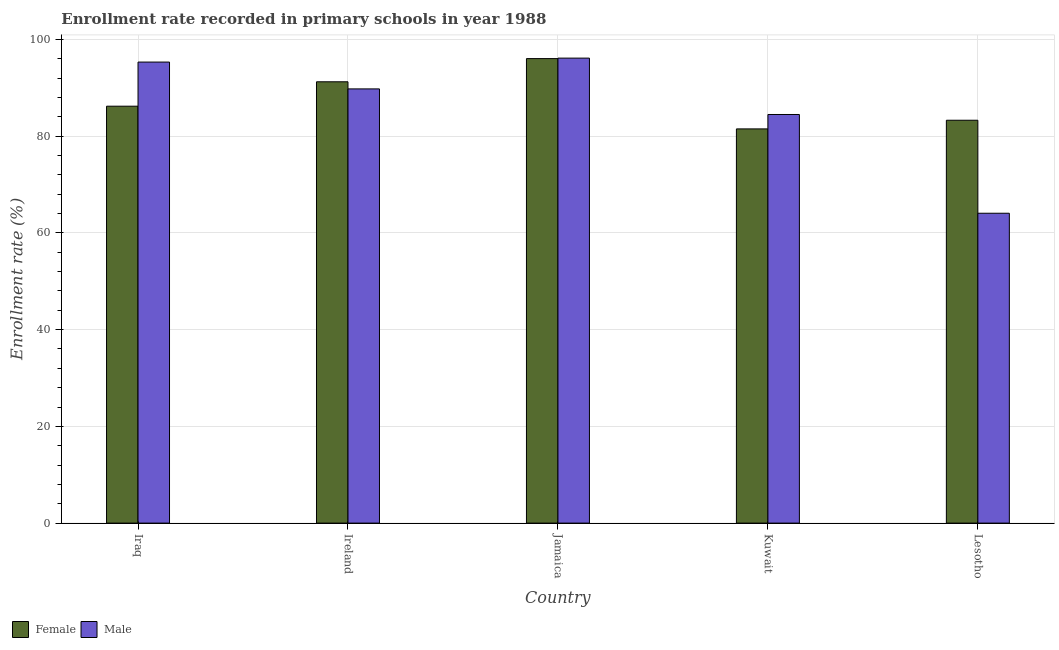How many groups of bars are there?
Provide a succinct answer. 5. Are the number of bars per tick equal to the number of legend labels?
Your answer should be very brief. Yes. How many bars are there on the 3rd tick from the left?
Keep it short and to the point. 2. What is the label of the 1st group of bars from the left?
Give a very brief answer. Iraq. What is the enrollment rate of male students in Lesotho?
Offer a very short reply. 64.07. Across all countries, what is the maximum enrollment rate of female students?
Offer a very short reply. 96.05. Across all countries, what is the minimum enrollment rate of male students?
Provide a succinct answer. 64.07. In which country was the enrollment rate of female students maximum?
Provide a short and direct response. Jamaica. In which country was the enrollment rate of female students minimum?
Your answer should be compact. Kuwait. What is the total enrollment rate of male students in the graph?
Keep it short and to the point. 429.81. What is the difference between the enrollment rate of female students in Iraq and that in Lesotho?
Ensure brevity in your answer.  2.9. What is the difference between the enrollment rate of female students in Iraq and the enrollment rate of male students in Jamaica?
Provide a short and direct response. -9.94. What is the average enrollment rate of male students per country?
Your answer should be very brief. 85.96. What is the difference between the enrollment rate of male students and enrollment rate of female students in Ireland?
Make the answer very short. -1.47. What is the ratio of the enrollment rate of female students in Iraq to that in Kuwait?
Make the answer very short. 1.06. Is the enrollment rate of male students in Iraq less than that in Lesotho?
Provide a short and direct response. No. What is the difference between the highest and the second highest enrollment rate of female students?
Provide a short and direct response. 4.8. What is the difference between the highest and the lowest enrollment rate of female students?
Ensure brevity in your answer.  14.54. In how many countries, is the enrollment rate of female students greater than the average enrollment rate of female students taken over all countries?
Your response must be concise. 2. What does the 1st bar from the left in Kuwait represents?
Provide a succinct answer. Female. Are all the bars in the graph horizontal?
Provide a succinct answer. No. Are the values on the major ticks of Y-axis written in scientific E-notation?
Offer a terse response. No. Does the graph contain any zero values?
Your answer should be very brief. No. Does the graph contain grids?
Provide a succinct answer. Yes. Where does the legend appear in the graph?
Your answer should be compact. Bottom left. How are the legend labels stacked?
Provide a short and direct response. Horizontal. What is the title of the graph?
Offer a terse response. Enrollment rate recorded in primary schools in year 1988. Does "% of gross capital formation" appear as one of the legend labels in the graph?
Make the answer very short. No. What is the label or title of the X-axis?
Your answer should be very brief. Country. What is the label or title of the Y-axis?
Offer a terse response. Enrollment rate (%). What is the Enrollment rate (%) in Female in Iraq?
Offer a terse response. 86.2. What is the Enrollment rate (%) in Male in Iraq?
Give a very brief answer. 95.33. What is the Enrollment rate (%) of Female in Ireland?
Your answer should be very brief. 91.25. What is the Enrollment rate (%) in Male in Ireland?
Provide a succinct answer. 89.78. What is the Enrollment rate (%) in Female in Jamaica?
Give a very brief answer. 96.05. What is the Enrollment rate (%) in Male in Jamaica?
Give a very brief answer. 96.14. What is the Enrollment rate (%) of Female in Kuwait?
Offer a very short reply. 81.51. What is the Enrollment rate (%) in Male in Kuwait?
Keep it short and to the point. 84.49. What is the Enrollment rate (%) of Female in Lesotho?
Provide a succinct answer. 83.3. What is the Enrollment rate (%) of Male in Lesotho?
Make the answer very short. 64.07. Across all countries, what is the maximum Enrollment rate (%) in Female?
Make the answer very short. 96.05. Across all countries, what is the maximum Enrollment rate (%) in Male?
Provide a succinct answer. 96.14. Across all countries, what is the minimum Enrollment rate (%) of Female?
Offer a terse response. 81.51. Across all countries, what is the minimum Enrollment rate (%) in Male?
Offer a terse response. 64.07. What is the total Enrollment rate (%) in Female in the graph?
Give a very brief answer. 438.31. What is the total Enrollment rate (%) of Male in the graph?
Your response must be concise. 429.81. What is the difference between the Enrollment rate (%) of Female in Iraq and that in Ireland?
Your answer should be compact. -5.05. What is the difference between the Enrollment rate (%) in Male in Iraq and that in Ireland?
Provide a succinct answer. 5.55. What is the difference between the Enrollment rate (%) in Female in Iraq and that in Jamaica?
Keep it short and to the point. -9.84. What is the difference between the Enrollment rate (%) of Male in Iraq and that in Jamaica?
Provide a succinct answer. -0.82. What is the difference between the Enrollment rate (%) of Female in Iraq and that in Kuwait?
Make the answer very short. 4.7. What is the difference between the Enrollment rate (%) of Male in Iraq and that in Kuwait?
Your response must be concise. 10.84. What is the difference between the Enrollment rate (%) in Female in Iraq and that in Lesotho?
Provide a succinct answer. 2.9. What is the difference between the Enrollment rate (%) of Male in Iraq and that in Lesotho?
Provide a succinct answer. 31.26. What is the difference between the Enrollment rate (%) of Female in Ireland and that in Jamaica?
Make the answer very short. -4.8. What is the difference between the Enrollment rate (%) of Male in Ireland and that in Jamaica?
Provide a succinct answer. -6.36. What is the difference between the Enrollment rate (%) of Female in Ireland and that in Kuwait?
Provide a short and direct response. 9.74. What is the difference between the Enrollment rate (%) of Male in Ireland and that in Kuwait?
Your answer should be compact. 5.29. What is the difference between the Enrollment rate (%) in Female in Ireland and that in Lesotho?
Provide a succinct answer. 7.95. What is the difference between the Enrollment rate (%) in Male in Ireland and that in Lesotho?
Your answer should be very brief. 25.71. What is the difference between the Enrollment rate (%) of Female in Jamaica and that in Kuwait?
Give a very brief answer. 14.54. What is the difference between the Enrollment rate (%) in Male in Jamaica and that in Kuwait?
Give a very brief answer. 11.66. What is the difference between the Enrollment rate (%) of Female in Jamaica and that in Lesotho?
Provide a short and direct response. 12.75. What is the difference between the Enrollment rate (%) of Male in Jamaica and that in Lesotho?
Your answer should be very brief. 32.07. What is the difference between the Enrollment rate (%) of Female in Kuwait and that in Lesotho?
Your answer should be compact. -1.79. What is the difference between the Enrollment rate (%) in Male in Kuwait and that in Lesotho?
Provide a short and direct response. 20.42. What is the difference between the Enrollment rate (%) of Female in Iraq and the Enrollment rate (%) of Male in Ireland?
Provide a succinct answer. -3.58. What is the difference between the Enrollment rate (%) in Female in Iraq and the Enrollment rate (%) in Male in Jamaica?
Your answer should be very brief. -9.94. What is the difference between the Enrollment rate (%) of Female in Iraq and the Enrollment rate (%) of Male in Kuwait?
Offer a very short reply. 1.72. What is the difference between the Enrollment rate (%) of Female in Iraq and the Enrollment rate (%) of Male in Lesotho?
Keep it short and to the point. 22.13. What is the difference between the Enrollment rate (%) in Female in Ireland and the Enrollment rate (%) in Male in Jamaica?
Offer a very short reply. -4.89. What is the difference between the Enrollment rate (%) in Female in Ireland and the Enrollment rate (%) in Male in Kuwait?
Offer a terse response. 6.76. What is the difference between the Enrollment rate (%) of Female in Ireland and the Enrollment rate (%) of Male in Lesotho?
Provide a short and direct response. 27.18. What is the difference between the Enrollment rate (%) of Female in Jamaica and the Enrollment rate (%) of Male in Kuwait?
Offer a very short reply. 11.56. What is the difference between the Enrollment rate (%) of Female in Jamaica and the Enrollment rate (%) of Male in Lesotho?
Your response must be concise. 31.98. What is the difference between the Enrollment rate (%) of Female in Kuwait and the Enrollment rate (%) of Male in Lesotho?
Keep it short and to the point. 17.44. What is the average Enrollment rate (%) of Female per country?
Offer a terse response. 87.66. What is the average Enrollment rate (%) in Male per country?
Offer a very short reply. 85.96. What is the difference between the Enrollment rate (%) in Female and Enrollment rate (%) in Male in Iraq?
Keep it short and to the point. -9.12. What is the difference between the Enrollment rate (%) of Female and Enrollment rate (%) of Male in Ireland?
Your answer should be very brief. 1.47. What is the difference between the Enrollment rate (%) in Female and Enrollment rate (%) in Male in Jamaica?
Provide a succinct answer. -0.1. What is the difference between the Enrollment rate (%) of Female and Enrollment rate (%) of Male in Kuwait?
Keep it short and to the point. -2.98. What is the difference between the Enrollment rate (%) in Female and Enrollment rate (%) in Male in Lesotho?
Provide a succinct answer. 19.23. What is the ratio of the Enrollment rate (%) in Female in Iraq to that in Ireland?
Ensure brevity in your answer.  0.94. What is the ratio of the Enrollment rate (%) of Male in Iraq to that in Ireland?
Your answer should be compact. 1.06. What is the ratio of the Enrollment rate (%) of Female in Iraq to that in Jamaica?
Offer a very short reply. 0.9. What is the ratio of the Enrollment rate (%) in Male in Iraq to that in Jamaica?
Ensure brevity in your answer.  0.99. What is the ratio of the Enrollment rate (%) in Female in Iraq to that in Kuwait?
Your answer should be compact. 1.06. What is the ratio of the Enrollment rate (%) in Male in Iraq to that in Kuwait?
Your response must be concise. 1.13. What is the ratio of the Enrollment rate (%) in Female in Iraq to that in Lesotho?
Offer a terse response. 1.03. What is the ratio of the Enrollment rate (%) in Male in Iraq to that in Lesotho?
Keep it short and to the point. 1.49. What is the ratio of the Enrollment rate (%) in Female in Ireland to that in Jamaica?
Provide a short and direct response. 0.95. What is the ratio of the Enrollment rate (%) in Male in Ireland to that in Jamaica?
Offer a terse response. 0.93. What is the ratio of the Enrollment rate (%) in Female in Ireland to that in Kuwait?
Your answer should be very brief. 1.12. What is the ratio of the Enrollment rate (%) of Male in Ireland to that in Kuwait?
Provide a short and direct response. 1.06. What is the ratio of the Enrollment rate (%) of Female in Ireland to that in Lesotho?
Your answer should be compact. 1.1. What is the ratio of the Enrollment rate (%) of Male in Ireland to that in Lesotho?
Make the answer very short. 1.4. What is the ratio of the Enrollment rate (%) of Female in Jamaica to that in Kuwait?
Your response must be concise. 1.18. What is the ratio of the Enrollment rate (%) of Male in Jamaica to that in Kuwait?
Provide a short and direct response. 1.14. What is the ratio of the Enrollment rate (%) in Female in Jamaica to that in Lesotho?
Offer a terse response. 1.15. What is the ratio of the Enrollment rate (%) in Male in Jamaica to that in Lesotho?
Provide a short and direct response. 1.5. What is the ratio of the Enrollment rate (%) in Female in Kuwait to that in Lesotho?
Your response must be concise. 0.98. What is the ratio of the Enrollment rate (%) of Male in Kuwait to that in Lesotho?
Make the answer very short. 1.32. What is the difference between the highest and the second highest Enrollment rate (%) in Female?
Keep it short and to the point. 4.8. What is the difference between the highest and the second highest Enrollment rate (%) of Male?
Offer a terse response. 0.82. What is the difference between the highest and the lowest Enrollment rate (%) in Female?
Offer a very short reply. 14.54. What is the difference between the highest and the lowest Enrollment rate (%) of Male?
Keep it short and to the point. 32.07. 